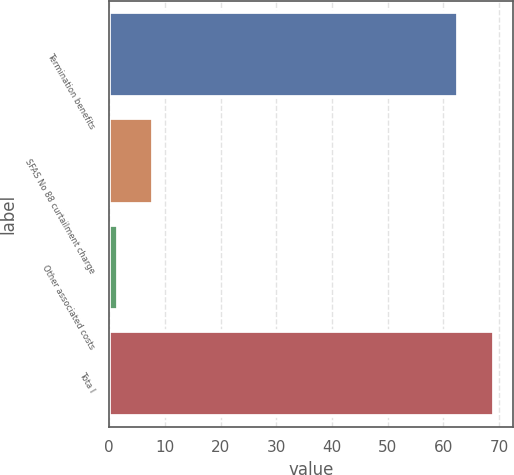Convert chart to OTSL. <chart><loc_0><loc_0><loc_500><loc_500><bar_chart><fcel>Termination benefits<fcel>SFAS No 88 curtailment charge<fcel>Other associated costs<fcel>Tota l<nl><fcel>62.7<fcel>7.93<fcel>1.5<fcel>69.13<nl></chart> 